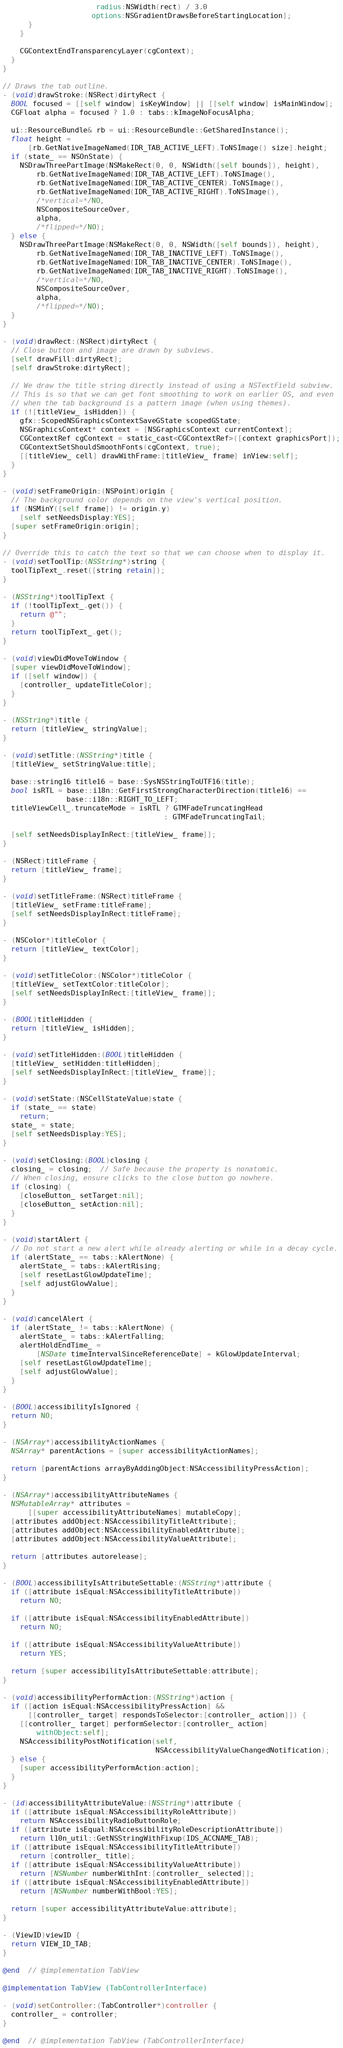Convert code to text. <code><loc_0><loc_0><loc_500><loc_500><_ObjectiveC_>                      radius:NSWidth(rect) / 3.0
                     options:NSGradientDrawsBeforeStartingLocation];
      }
    }

    CGContextEndTransparencyLayer(cgContext);
  }
}

// Draws the tab outline.
- (void)drawStroke:(NSRect)dirtyRect {
  BOOL focused = [[self window] isKeyWindow] || [[self window] isMainWindow];
  CGFloat alpha = focused ? 1.0 : tabs::kImageNoFocusAlpha;

  ui::ResourceBundle& rb = ui::ResourceBundle::GetSharedInstance();
  float height =
      [rb.GetNativeImageNamed(IDR_TAB_ACTIVE_LEFT).ToNSImage() size].height;
  if (state_ == NSOnState) {
    NSDrawThreePartImage(NSMakeRect(0, 0, NSWidth([self bounds]), height),
        rb.GetNativeImageNamed(IDR_TAB_ACTIVE_LEFT).ToNSImage(),
        rb.GetNativeImageNamed(IDR_TAB_ACTIVE_CENTER).ToNSImage(),
        rb.GetNativeImageNamed(IDR_TAB_ACTIVE_RIGHT).ToNSImage(),
        /*vertical=*/NO,
        NSCompositeSourceOver,
        alpha,
        /*flipped=*/NO);
  } else {
    NSDrawThreePartImage(NSMakeRect(0, 0, NSWidth([self bounds]), height),
        rb.GetNativeImageNamed(IDR_TAB_INACTIVE_LEFT).ToNSImage(),
        rb.GetNativeImageNamed(IDR_TAB_INACTIVE_CENTER).ToNSImage(),
        rb.GetNativeImageNamed(IDR_TAB_INACTIVE_RIGHT).ToNSImage(),
        /*vertical=*/NO,
        NSCompositeSourceOver,
        alpha,
        /*flipped=*/NO);
  }
}

- (void)drawRect:(NSRect)dirtyRect {
  // Close button and image are drawn by subviews.
  [self drawFill:dirtyRect];
  [self drawStroke:dirtyRect];

  // We draw the title string directly instead of using a NSTextField subview.
  // This is so that we can get font smoothing to work on earlier OS, and even
  // when the tab background is a pattern image (when using themes).
  if (![titleView_ isHidden]) {
    gfx::ScopedNSGraphicsContextSaveGState scopedGState;
    NSGraphicsContext* context = [NSGraphicsContext currentContext];
    CGContextRef cgContext = static_cast<CGContextRef>([context graphicsPort]);
    CGContextSetShouldSmoothFonts(cgContext, true);
    [[titleView_ cell] drawWithFrame:[titleView_ frame] inView:self];
  }
}

- (void)setFrameOrigin:(NSPoint)origin {
  // The background color depends on the view's vertical position.
  if (NSMinY([self frame]) != origin.y)
    [self setNeedsDisplay:YES];
  [super setFrameOrigin:origin];
}

// Override this to catch the text so that we can choose when to display it.
- (void)setToolTip:(NSString*)string {
  toolTipText_.reset([string retain]);
}

- (NSString*)toolTipText {
  if (!toolTipText_.get()) {
    return @"";
  }
  return toolTipText_.get();
}

- (void)viewDidMoveToWindow {
  [super viewDidMoveToWindow];
  if ([self window]) {
    [controller_ updateTitleColor];
  }
}

- (NSString*)title {
  return [titleView_ stringValue];
}

- (void)setTitle:(NSString*)title {
  [titleView_ setStringValue:title];

  base::string16 title16 = base::SysNSStringToUTF16(title);
  bool isRTL = base::i18n::GetFirstStrongCharacterDirection(title16) ==
               base::i18n::RIGHT_TO_LEFT;
  titleViewCell_.truncateMode = isRTL ? GTMFadeTruncatingHead
                                      : GTMFadeTruncatingTail;

  [self setNeedsDisplayInRect:[titleView_ frame]];
}

- (NSRect)titleFrame {
  return [titleView_ frame];
}

- (void)setTitleFrame:(NSRect)titleFrame {
  [titleView_ setFrame:titleFrame];
  [self setNeedsDisplayInRect:titleFrame];
}

- (NSColor*)titleColor {
  return [titleView_ textColor];
}

- (void)setTitleColor:(NSColor*)titleColor {
  [titleView_ setTextColor:titleColor];
  [self setNeedsDisplayInRect:[titleView_ frame]];
}

- (BOOL)titleHidden {
  return [titleView_ isHidden];
}

- (void)setTitleHidden:(BOOL)titleHidden {
  [titleView_ setHidden:titleHidden];
  [self setNeedsDisplayInRect:[titleView_ frame]];
}

- (void)setState:(NSCellStateValue)state {
  if (state_ == state)
    return;
  state_ = state;
  [self setNeedsDisplay:YES];
}

- (void)setClosing:(BOOL)closing {
  closing_ = closing;  // Safe because the property is nonatomic.
  // When closing, ensure clicks to the close button go nowhere.
  if (closing) {
    [closeButton_ setTarget:nil];
    [closeButton_ setAction:nil];
  }
}

- (void)startAlert {
  // Do not start a new alert while already alerting or while in a decay cycle.
  if (alertState_ == tabs::kAlertNone) {
    alertState_ = tabs::kAlertRising;
    [self resetLastGlowUpdateTime];
    [self adjustGlowValue];
  }
}

- (void)cancelAlert {
  if (alertState_ != tabs::kAlertNone) {
    alertState_ = tabs::kAlertFalling;
    alertHoldEndTime_ =
        [NSDate timeIntervalSinceReferenceDate] + kGlowUpdateInterval;
    [self resetLastGlowUpdateTime];
    [self adjustGlowValue];
  }
}

- (BOOL)accessibilityIsIgnored {
  return NO;
}

- (NSArray*)accessibilityActionNames {
  NSArray* parentActions = [super accessibilityActionNames];

  return [parentActions arrayByAddingObject:NSAccessibilityPressAction];
}

- (NSArray*)accessibilityAttributeNames {
  NSMutableArray* attributes =
      [[super accessibilityAttributeNames] mutableCopy];
  [attributes addObject:NSAccessibilityTitleAttribute];
  [attributes addObject:NSAccessibilityEnabledAttribute];
  [attributes addObject:NSAccessibilityValueAttribute];

  return [attributes autorelease];
}

- (BOOL)accessibilityIsAttributeSettable:(NSString*)attribute {
  if ([attribute isEqual:NSAccessibilityTitleAttribute])
    return NO;

  if ([attribute isEqual:NSAccessibilityEnabledAttribute])
    return NO;

  if ([attribute isEqual:NSAccessibilityValueAttribute])
    return YES;

  return [super accessibilityIsAttributeSettable:attribute];
}

- (void)accessibilityPerformAction:(NSString*)action {
  if ([action isEqual:NSAccessibilityPressAction] &&
      [[controller_ target] respondsToSelector:[controller_ action]]) {
    [[controller_ target] performSelector:[controller_ action]
        withObject:self];
    NSAccessibilityPostNotification(self,
                                    NSAccessibilityValueChangedNotification);
  } else {
    [super accessibilityPerformAction:action];
  }
}

- (id)accessibilityAttributeValue:(NSString*)attribute {
  if ([attribute isEqual:NSAccessibilityRoleAttribute])
    return NSAccessibilityRadioButtonRole;
  if ([attribute isEqual:NSAccessibilityRoleDescriptionAttribute])
    return l10n_util::GetNSStringWithFixup(IDS_ACCNAME_TAB);
  if ([attribute isEqual:NSAccessibilityTitleAttribute])
    return [controller_ title];
  if ([attribute isEqual:NSAccessibilityValueAttribute])
    return [NSNumber numberWithInt:[controller_ selected]];
  if ([attribute isEqual:NSAccessibilityEnabledAttribute])
    return [NSNumber numberWithBool:YES];

  return [super accessibilityAttributeValue:attribute];
}

- (ViewID)viewID {
  return VIEW_ID_TAB;
}

@end  // @implementation TabView

@implementation TabView (TabControllerInterface)

- (void)setController:(TabController*)controller {
  controller_ = controller;
}

@end  // @implementation TabView (TabControllerInterface)
</code> 